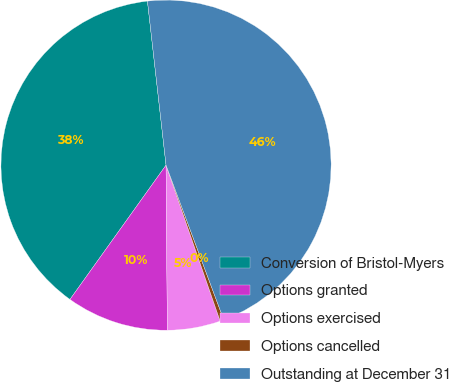Convert chart to OTSL. <chart><loc_0><loc_0><loc_500><loc_500><pie_chart><fcel>Conversion of Bristol-Myers<fcel>Options granted<fcel>Options exercised<fcel>Options cancelled<fcel>Outstanding at December 31<nl><fcel>38.32%<fcel>10.01%<fcel>5.19%<fcel>0.37%<fcel>46.11%<nl></chart> 